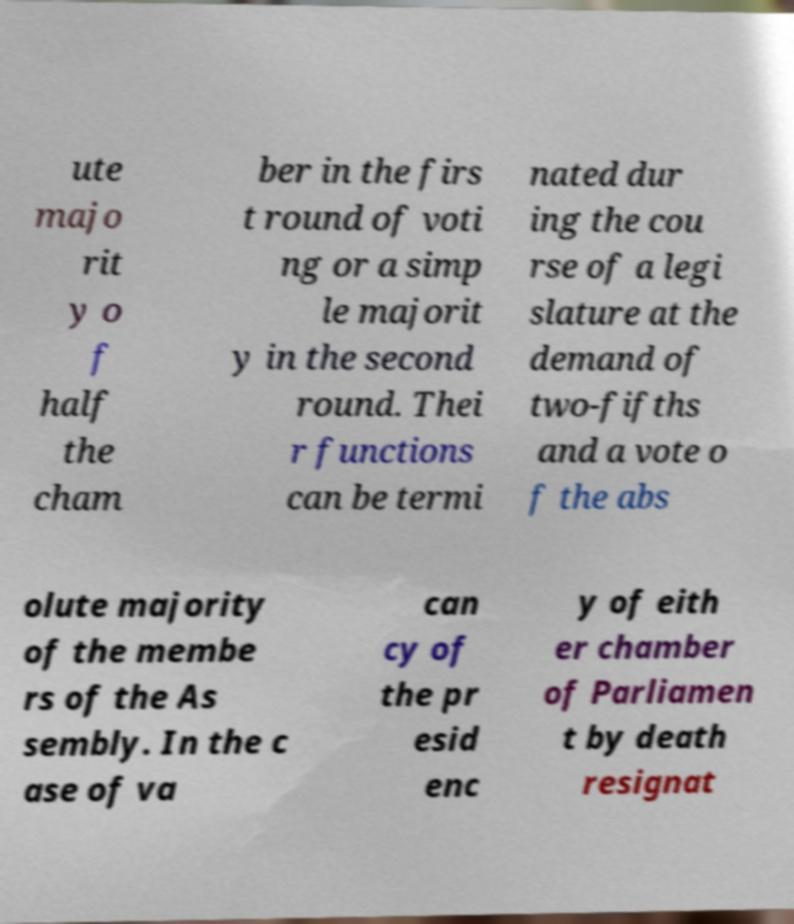Could you assist in decoding the text presented in this image and type it out clearly? ute majo rit y o f half the cham ber in the firs t round of voti ng or a simp le majorit y in the second round. Thei r functions can be termi nated dur ing the cou rse of a legi slature at the demand of two-fifths and a vote o f the abs olute majority of the membe rs of the As sembly. In the c ase of va can cy of the pr esid enc y of eith er chamber of Parliamen t by death resignat 